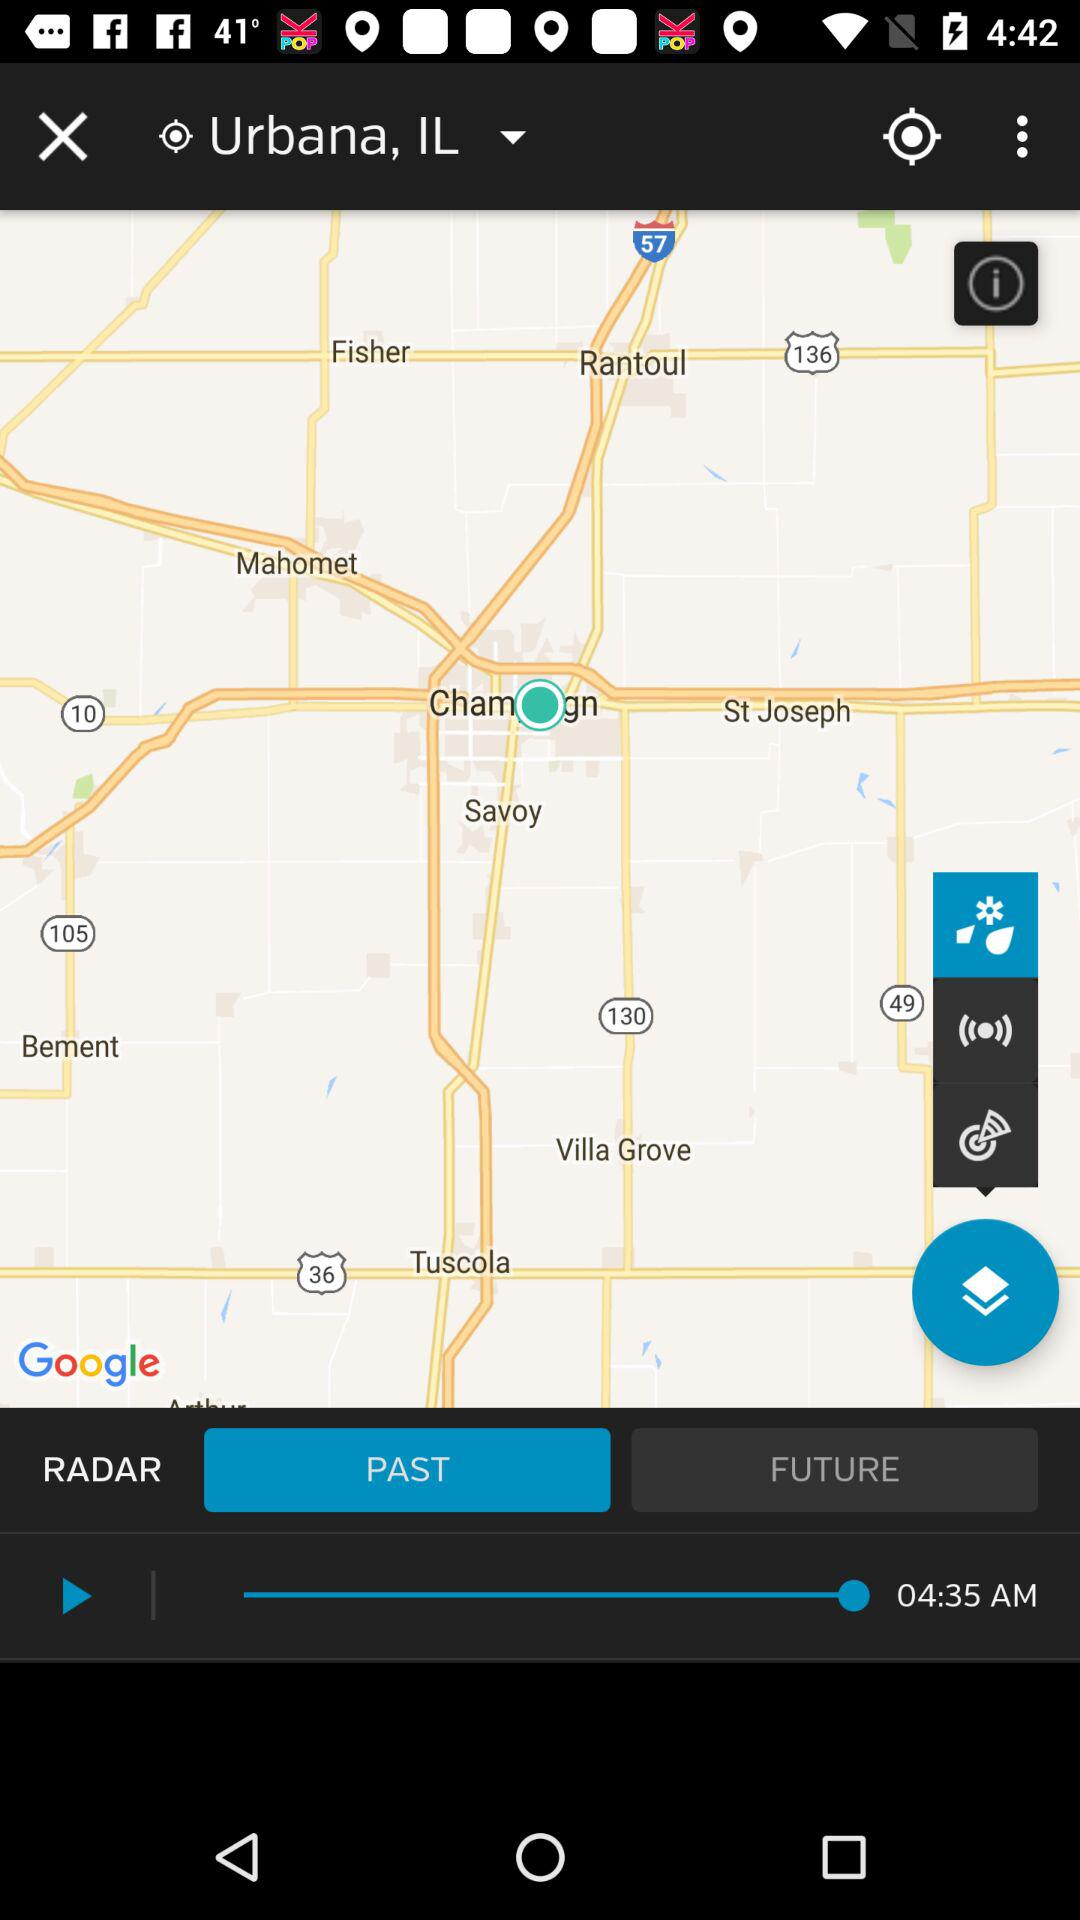What is the selected location? The selected location is Urbana, IL. 